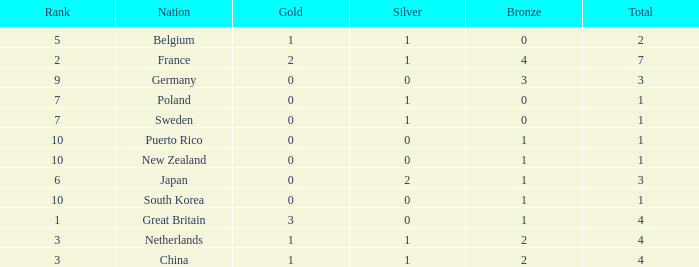What is the rank with 0 bronze? None. 